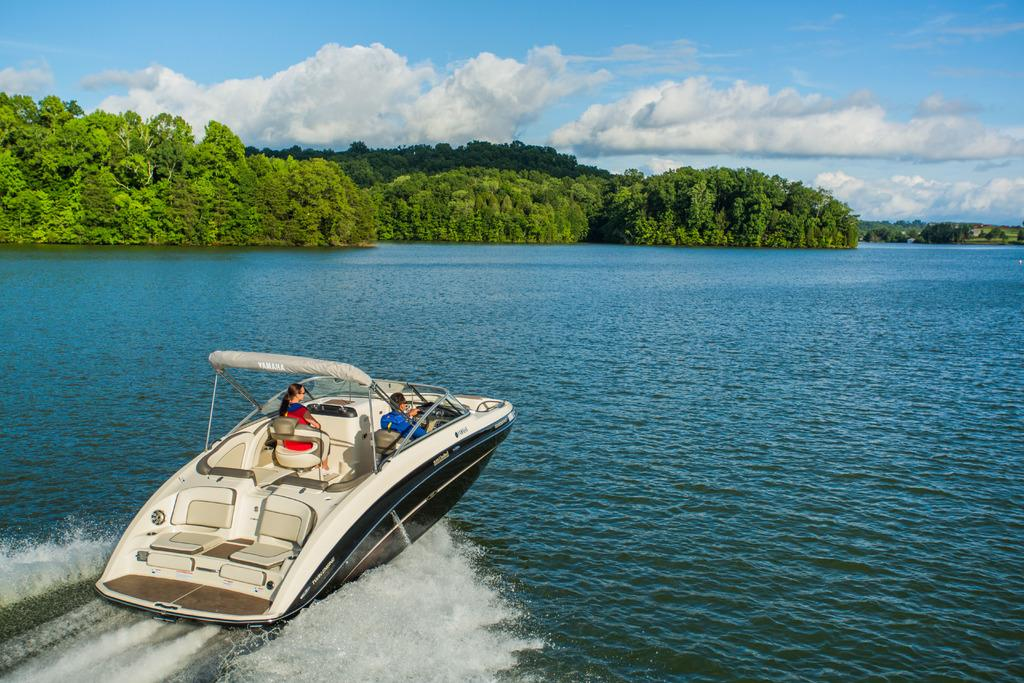How many people are in the image? There are two people in the image. What are the people doing in the image? The people are boating on the water. What type of natural environment can be seen in the image? There are trees and a land with grass visible in the image. What color is the balloon that the man is holding in the image? There is no man or balloon present in the image. 